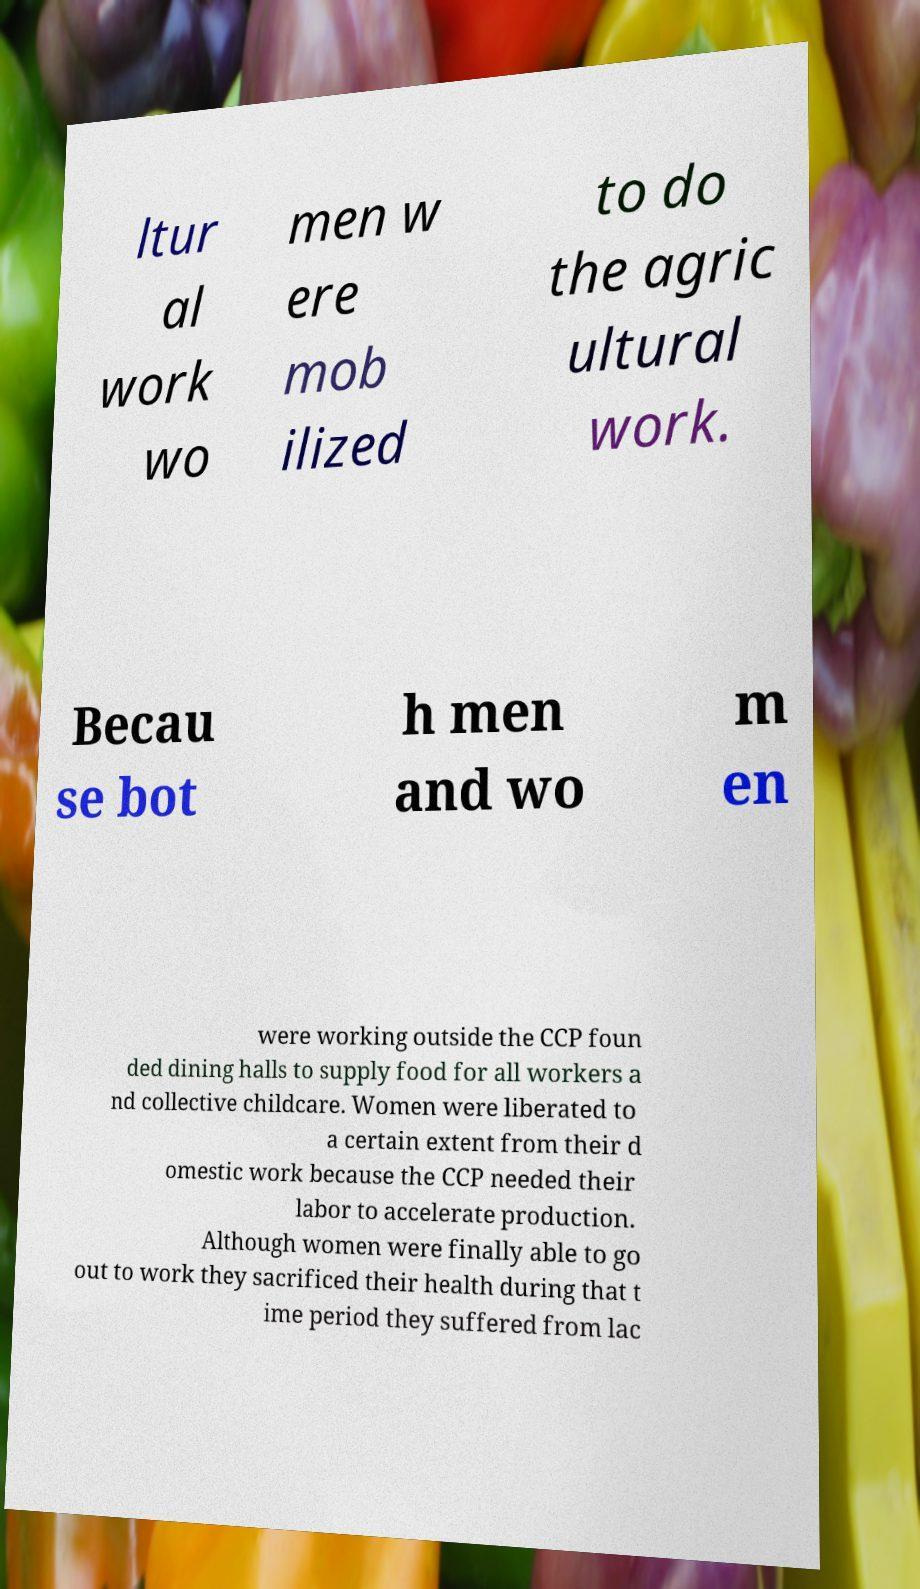Can you accurately transcribe the text from the provided image for me? ltur al work wo men w ere mob ilized to do the agric ultural work. Becau se bot h men and wo m en were working outside the CCP foun ded dining halls to supply food for all workers a nd collective childcare. Women were liberated to a certain extent from their d omestic work because the CCP needed their labor to accelerate production. Although women were finally able to go out to work they sacrificed their health during that t ime period they suffered from lac 